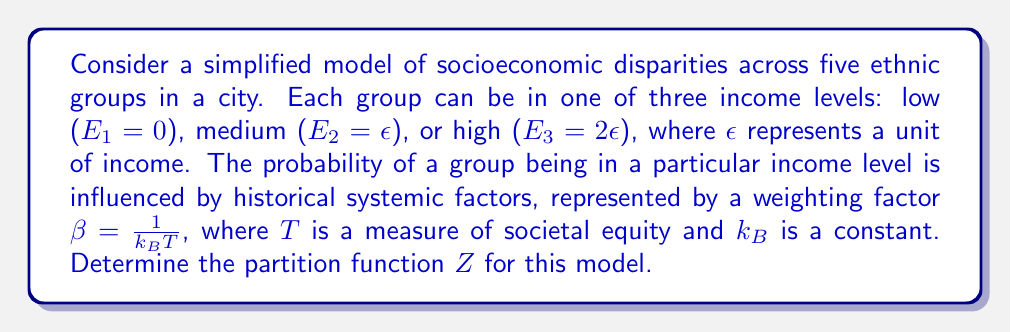Provide a solution to this math problem. To solve this problem, we'll follow these steps:

1) Recall that the partition function $Z$ is the sum of all possible Boltzmann factors:

   $$Z = \sum_i e^{-\beta E_i}$$

2) In this case, we have three energy levels for each of the five groups:
   $E_1 = 0$, $E_2 = \epsilon$, $E_3 = 2\epsilon$

3) The Boltzmann factors for each level are:
   - For $E_1$: $e^{-\beta \cdot 0} = 1$
   - For $E_2$: $e^{-\beta \epsilon}$
   - For $E_3$: $e^{-\beta (2\epsilon)} = (e^{-\beta \epsilon})^2$

4) For a single group, the partition function would be:
   $$Z_1 = 1 + e^{-\beta \epsilon} + e^{-2\beta \epsilon}$$

5) Since we have five independent groups, and each group can be in any of these states, the total partition function is the product of the individual partition functions:

   $$Z = (Z_1)^5 = (1 + e^{-\beta \epsilon} + e^{-2\beta \epsilon})^5$$

This formula represents the partition function for the given model of socioeconomic disparities across five ethnic groups.
Answer: $$(1 + e^{-\beta \epsilon} + e^{-2\beta \epsilon})^5$$ 